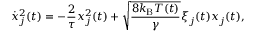<formula> <loc_0><loc_0><loc_500><loc_500>\dot { x } _ { j } ^ { 2 } ( t ) = - \frac { 2 } { \tau } x _ { j } ^ { 2 } ( t ) + \sqrt { \frac { 8 k _ { B } T ( t ) } { \gamma } } \xi _ { j } ( t ) x _ { j } ( t ) ,</formula> 